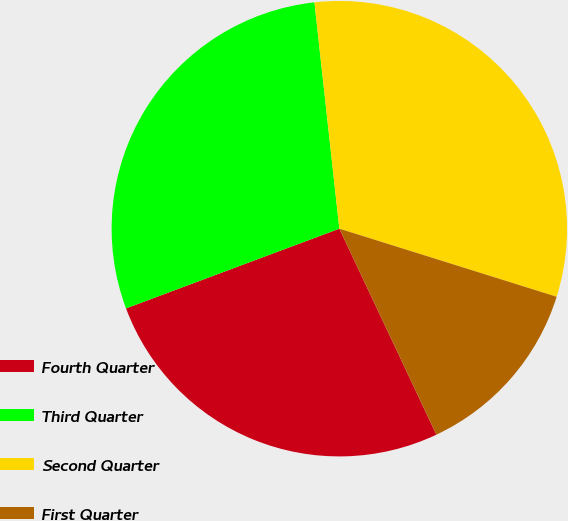<chart> <loc_0><loc_0><loc_500><loc_500><pie_chart><fcel>Fourth Quarter<fcel>Third Quarter<fcel>Second Quarter<fcel>First Quarter<nl><fcel>26.32%<fcel>28.95%<fcel>31.58%<fcel>13.16%<nl></chart> 